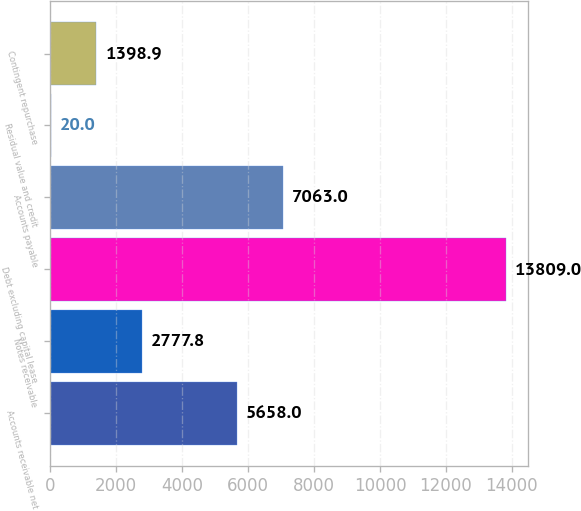Convert chart. <chart><loc_0><loc_0><loc_500><loc_500><bar_chart><fcel>Accounts receivable net<fcel>Notes receivable<fcel>Debt excluding capital lease<fcel>Accounts payable<fcel>Residual value and credit<fcel>Contingent repurchase<nl><fcel>5658<fcel>2777.8<fcel>13809<fcel>7063<fcel>20<fcel>1398.9<nl></chart> 